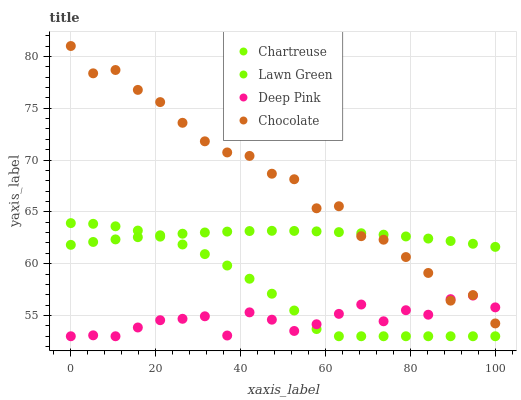Does Deep Pink have the minimum area under the curve?
Answer yes or no. Yes. Does Chocolate have the maximum area under the curve?
Answer yes or no. Yes. Does Chartreuse have the minimum area under the curve?
Answer yes or no. No. Does Chartreuse have the maximum area under the curve?
Answer yes or no. No. Is Lawn Green the smoothest?
Answer yes or no. Yes. Is Chocolate the roughest?
Answer yes or no. Yes. Is Chartreuse the smoothest?
Answer yes or no. No. Is Chartreuse the roughest?
Answer yes or no. No. Does Chartreuse have the lowest value?
Answer yes or no. Yes. Does Chocolate have the lowest value?
Answer yes or no. No. Does Chocolate have the highest value?
Answer yes or no. Yes. Does Chartreuse have the highest value?
Answer yes or no. No. Is Deep Pink less than Lawn Green?
Answer yes or no. Yes. Is Lawn Green greater than Deep Pink?
Answer yes or no. Yes. Does Deep Pink intersect Chocolate?
Answer yes or no. Yes. Is Deep Pink less than Chocolate?
Answer yes or no. No. Is Deep Pink greater than Chocolate?
Answer yes or no. No. Does Deep Pink intersect Lawn Green?
Answer yes or no. No. 